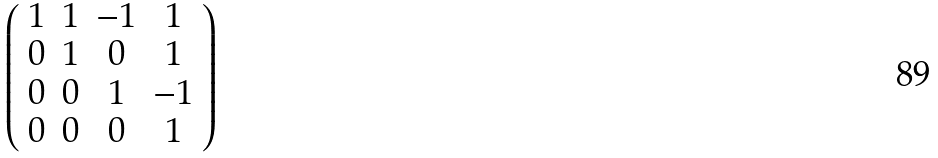Convert formula to latex. <formula><loc_0><loc_0><loc_500><loc_500>\left ( \begin{array} { c c c c } 1 & 1 & - 1 & 1 \\ 0 & 1 & 0 & 1 \\ 0 & 0 & 1 & - 1 \\ 0 & 0 & 0 & 1 \end{array} \right )</formula> 